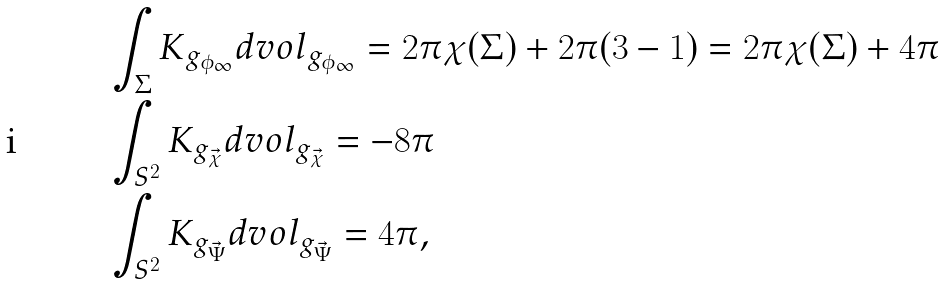<formula> <loc_0><loc_0><loc_500><loc_500>& \int _ { \Sigma } K _ { g _ { \phi _ { \infty } } } d v o l _ { g _ { \phi _ { \infty } } } = 2 \pi \chi ( \Sigma ) + 2 \pi ( 3 - 1 ) = 2 \pi \chi ( \Sigma ) + 4 \pi \\ & \int _ { S ^ { 2 } } K _ { g _ { \vec { \chi } } } d v o l _ { g _ { \vec { \chi } } } = - 8 \pi \\ & \int _ { S ^ { 2 } } K _ { g _ { \vec { \Psi } } } d v o l _ { g _ { \vec { \Psi } } } = 4 \pi ,</formula> 